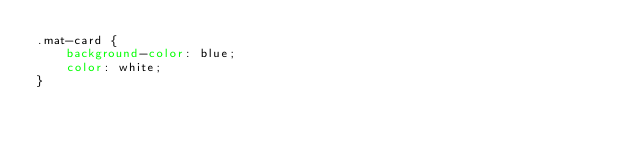Convert code to text. <code><loc_0><loc_0><loc_500><loc_500><_CSS_>.mat-card {
    background-color: blue;
    color: white;
}</code> 